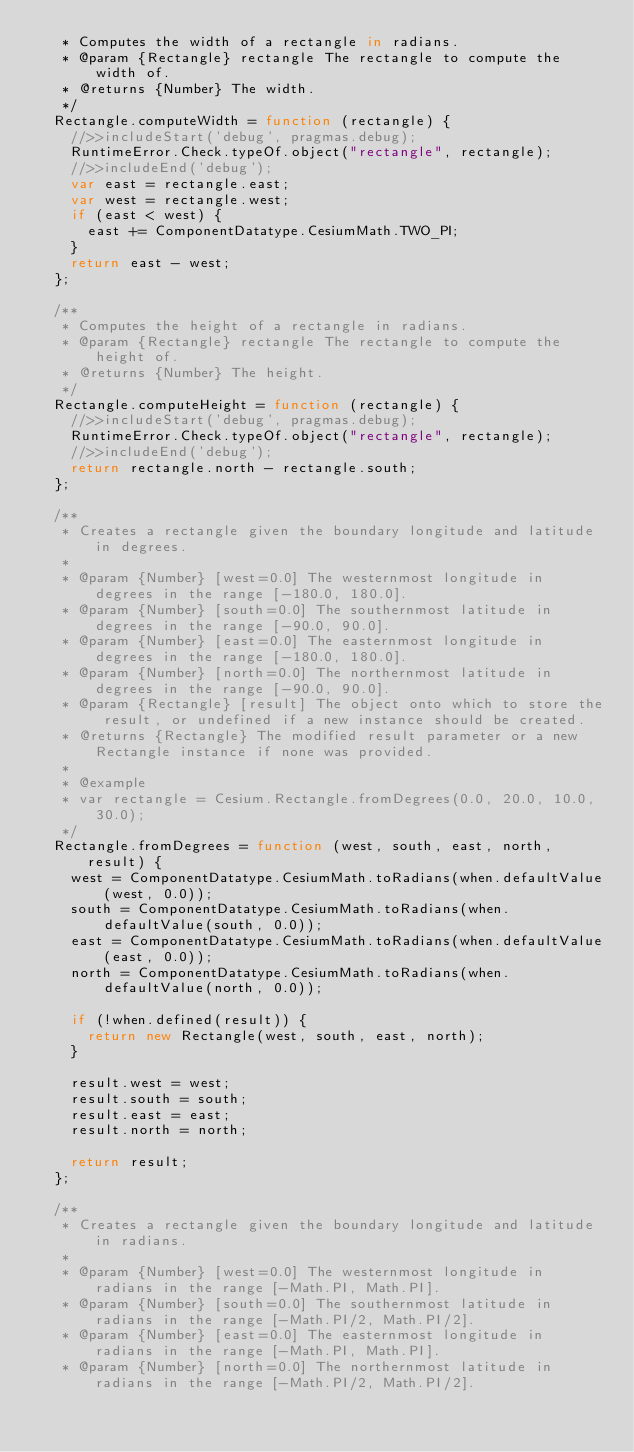<code> <loc_0><loc_0><loc_500><loc_500><_JavaScript_>   * Computes the width of a rectangle in radians.
   * @param {Rectangle} rectangle The rectangle to compute the width of.
   * @returns {Number} The width.
   */
  Rectangle.computeWidth = function (rectangle) {
    //>>includeStart('debug', pragmas.debug);
    RuntimeError.Check.typeOf.object("rectangle", rectangle);
    //>>includeEnd('debug');
    var east = rectangle.east;
    var west = rectangle.west;
    if (east < west) {
      east += ComponentDatatype.CesiumMath.TWO_PI;
    }
    return east - west;
  };

  /**
   * Computes the height of a rectangle in radians.
   * @param {Rectangle} rectangle The rectangle to compute the height of.
   * @returns {Number} The height.
   */
  Rectangle.computeHeight = function (rectangle) {
    //>>includeStart('debug', pragmas.debug);
    RuntimeError.Check.typeOf.object("rectangle", rectangle);
    //>>includeEnd('debug');
    return rectangle.north - rectangle.south;
  };

  /**
   * Creates a rectangle given the boundary longitude and latitude in degrees.
   *
   * @param {Number} [west=0.0] The westernmost longitude in degrees in the range [-180.0, 180.0].
   * @param {Number} [south=0.0] The southernmost latitude in degrees in the range [-90.0, 90.0].
   * @param {Number} [east=0.0] The easternmost longitude in degrees in the range [-180.0, 180.0].
   * @param {Number} [north=0.0] The northernmost latitude in degrees in the range [-90.0, 90.0].
   * @param {Rectangle} [result] The object onto which to store the result, or undefined if a new instance should be created.
   * @returns {Rectangle} The modified result parameter or a new Rectangle instance if none was provided.
   *
   * @example
   * var rectangle = Cesium.Rectangle.fromDegrees(0.0, 20.0, 10.0, 30.0);
   */
  Rectangle.fromDegrees = function (west, south, east, north, result) {
    west = ComponentDatatype.CesiumMath.toRadians(when.defaultValue(west, 0.0));
    south = ComponentDatatype.CesiumMath.toRadians(when.defaultValue(south, 0.0));
    east = ComponentDatatype.CesiumMath.toRadians(when.defaultValue(east, 0.0));
    north = ComponentDatatype.CesiumMath.toRadians(when.defaultValue(north, 0.0));

    if (!when.defined(result)) {
      return new Rectangle(west, south, east, north);
    }

    result.west = west;
    result.south = south;
    result.east = east;
    result.north = north;

    return result;
  };

  /**
   * Creates a rectangle given the boundary longitude and latitude in radians.
   *
   * @param {Number} [west=0.0] The westernmost longitude in radians in the range [-Math.PI, Math.PI].
   * @param {Number} [south=0.0] The southernmost latitude in radians in the range [-Math.PI/2, Math.PI/2].
   * @param {Number} [east=0.0] The easternmost longitude in radians in the range [-Math.PI, Math.PI].
   * @param {Number} [north=0.0] The northernmost latitude in radians in the range [-Math.PI/2, Math.PI/2].</code> 